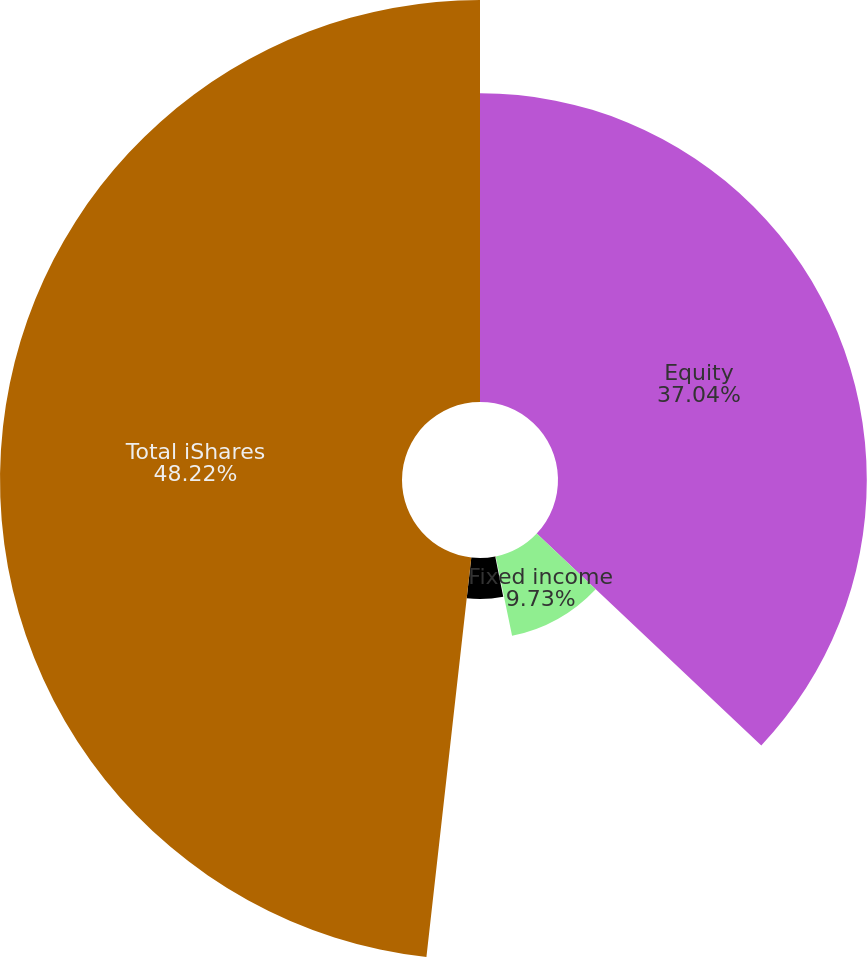<chart> <loc_0><loc_0><loc_500><loc_500><pie_chart><fcel>Equity<fcel>Fixed income<fcel>Multi-asset class<fcel>Alternatives (1)<fcel>Total iShares<nl><fcel>37.04%<fcel>9.73%<fcel>0.1%<fcel>4.91%<fcel>48.22%<nl></chart> 